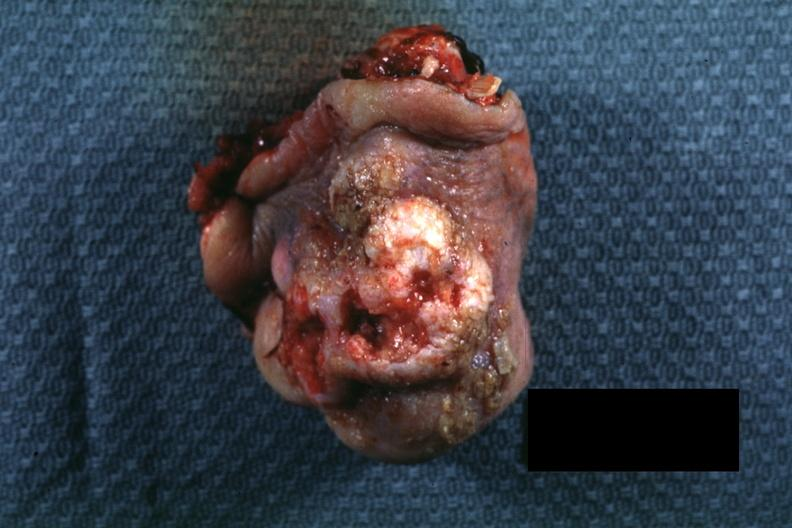does stein leventhal show portion of nose typical exophytic lesion with heaped-up margins and central ulceration?
Answer the question using a single word or phrase. No 